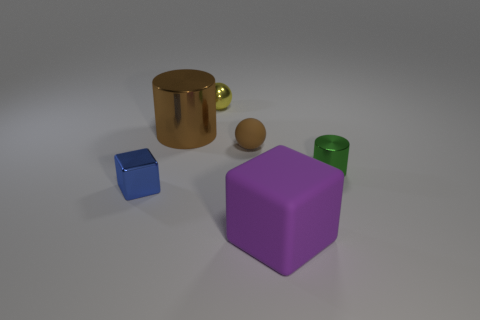Can you describe the colors of the objects? Sure, the objects in the image have various colors. There's a blue cube, a purple cube with a slightly larger size, a gold cylindrical object with a handle, suggesting it might be a mug, and the tiny matte sphere is a soft beige. 